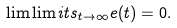<formula> <loc_0><loc_0><loc_500><loc_500>\lim \lim i t s _ { t \to \infty } e ( t ) = 0 .</formula> 